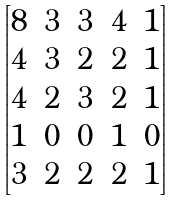Convert formula to latex. <formula><loc_0><loc_0><loc_500><loc_500>\begin{bmatrix} 8 & 3 & 3 & 4 & 1 \\ 4 & 3 & 2 & 2 & 1 \\ 4 & 2 & 3 & 2 & 1 \\ 1 & 0 & 0 & 1 & 0 \\ 3 & 2 & 2 & 2 & 1 \end{bmatrix}</formula> 